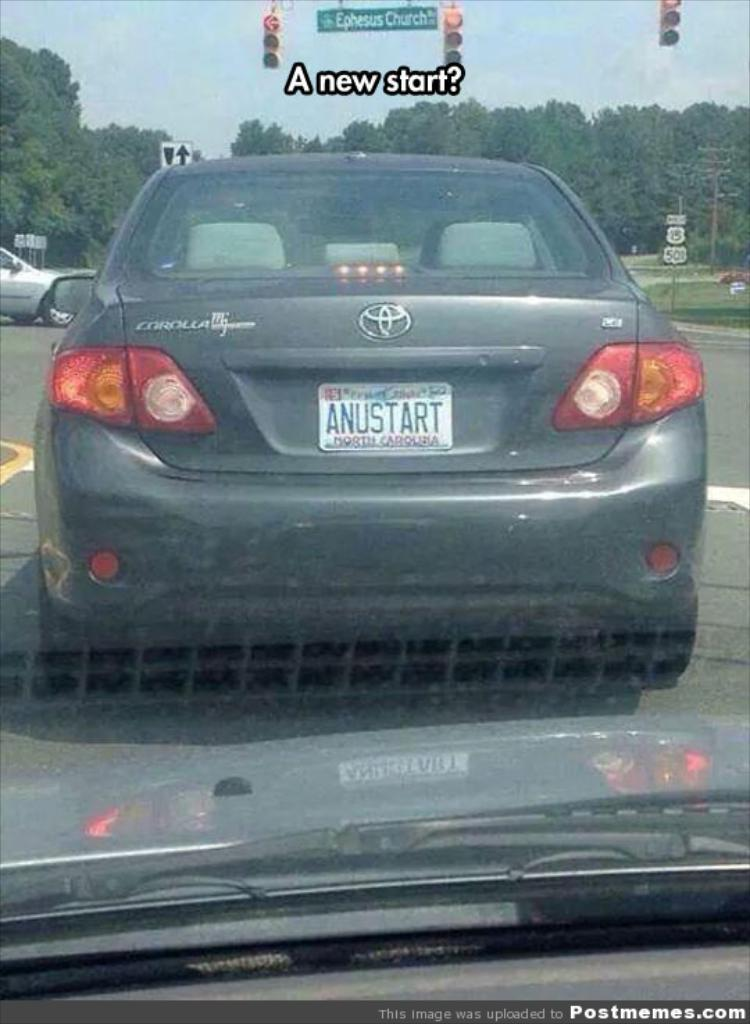<image>
Provide a brief description of the given image. a car that has the word anustart on the back 